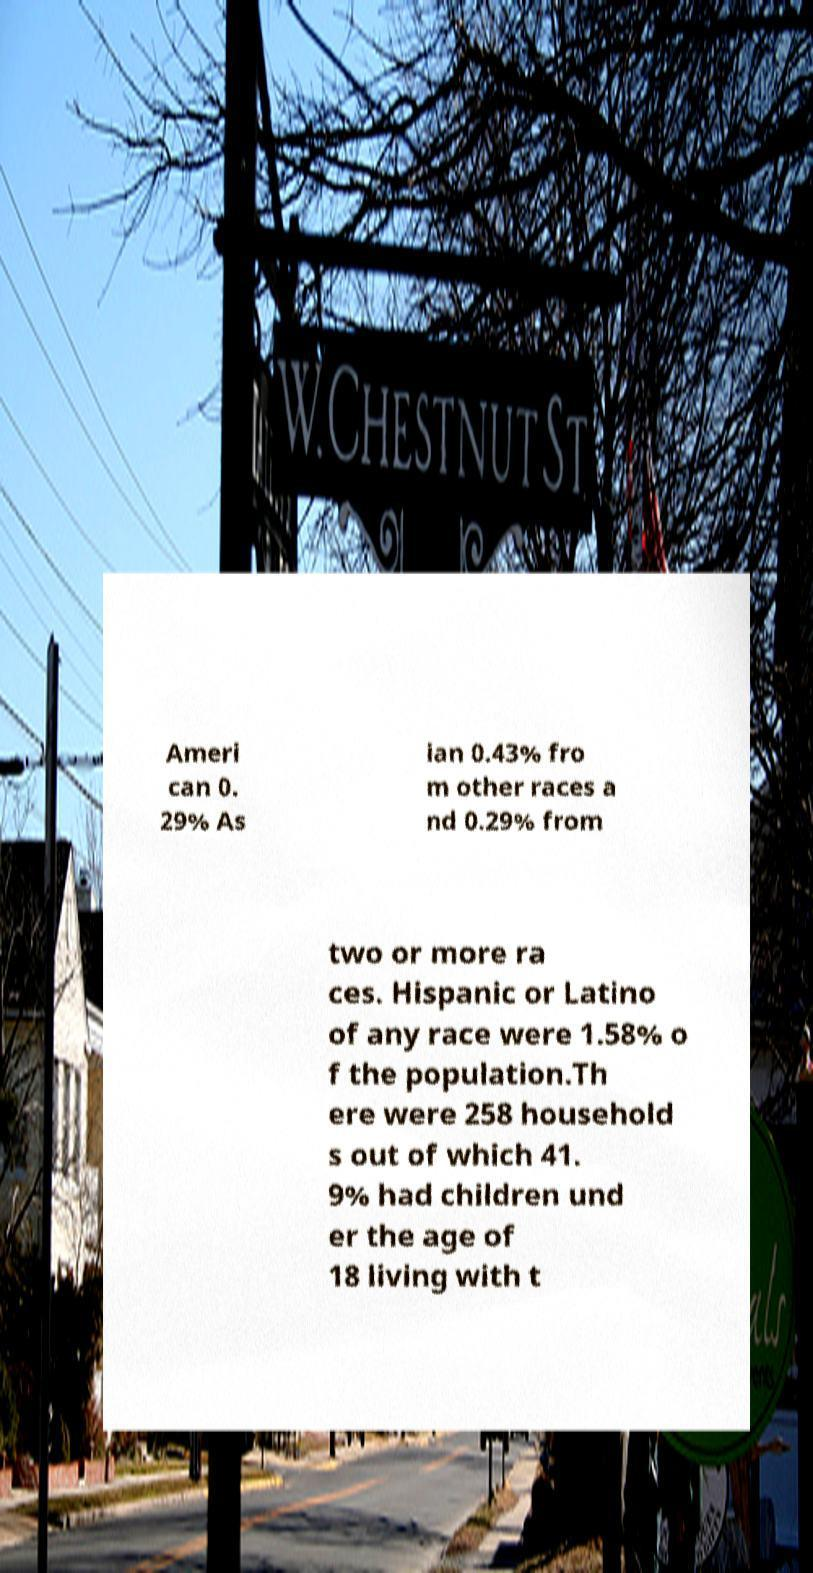Could you assist in decoding the text presented in this image and type it out clearly? Ameri can 0. 29% As ian 0.43% fro m other races a nd 0.29% from two or more ra ces. Hispanic or Latino of any race were 1.58% o f the population.Th ere were 258 household s out of which 41. 9% had children und er the age of 18 living with t 